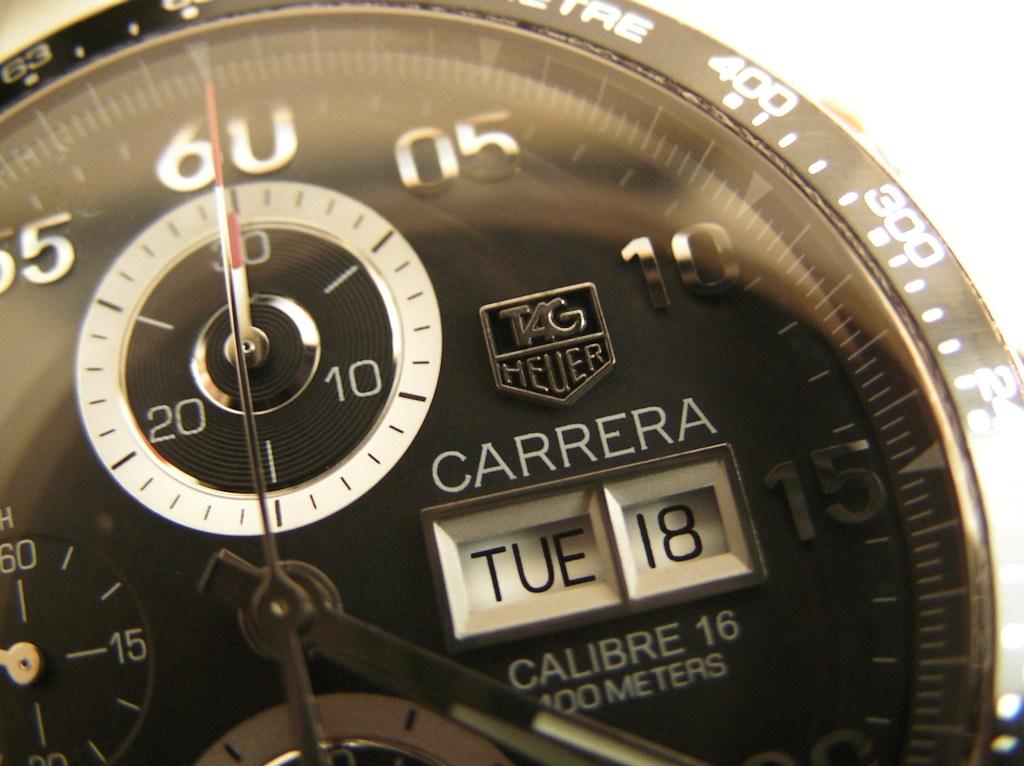What brand is this?
Give a very brief answer. Carrera. This bike speedometer?
Provide a short and direct response. No. 